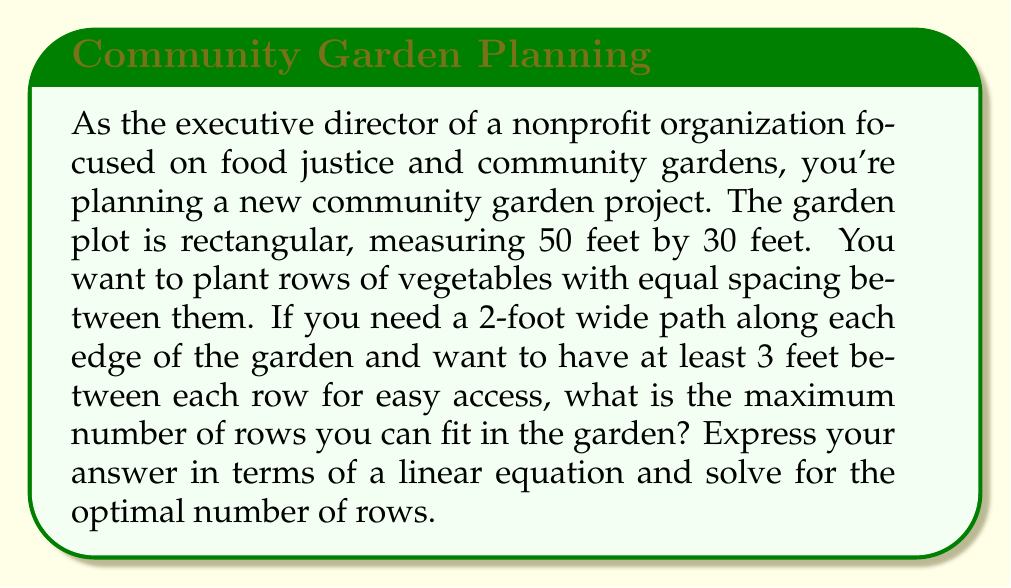Help me with this question. Let's approach this problem step-by-step using a linear equation:

1) First, we need to determine the available space for planting:
   - The garden is 30 feet wide
   - We need 2-foot paths on both sides: $30 - (2 \times 2) = 26$ feet available

2) Let $x$ be the number of rows we can fit in the garden.

3) Each row needs at least 3 feet of space. So the total space needed for $x$ rows is $3x$.

4) We can express this as a linear inequality:
   $$ 3x \leq 26 $$

5) This inequality represents that the total space needed for the rows (3x) must be less than or equal to the available space (26 feet).

6) To find the maximum number of rows, we solve the equation:
   $$ 3x = 26 $$

7) Solving for $x$:
   $$ x = \frac{26}{3} \approx 8.67 $$

8) Since we can't have a fractional number of rows, we round down to the nearest whole number.

Therefore, the maximum number of rows we can fit is 8.
Answer: The maximum number of rows that can be fitted in the garden is 8, based on the linear equation $3x = 26$, where $x$ represents the number of rows. 